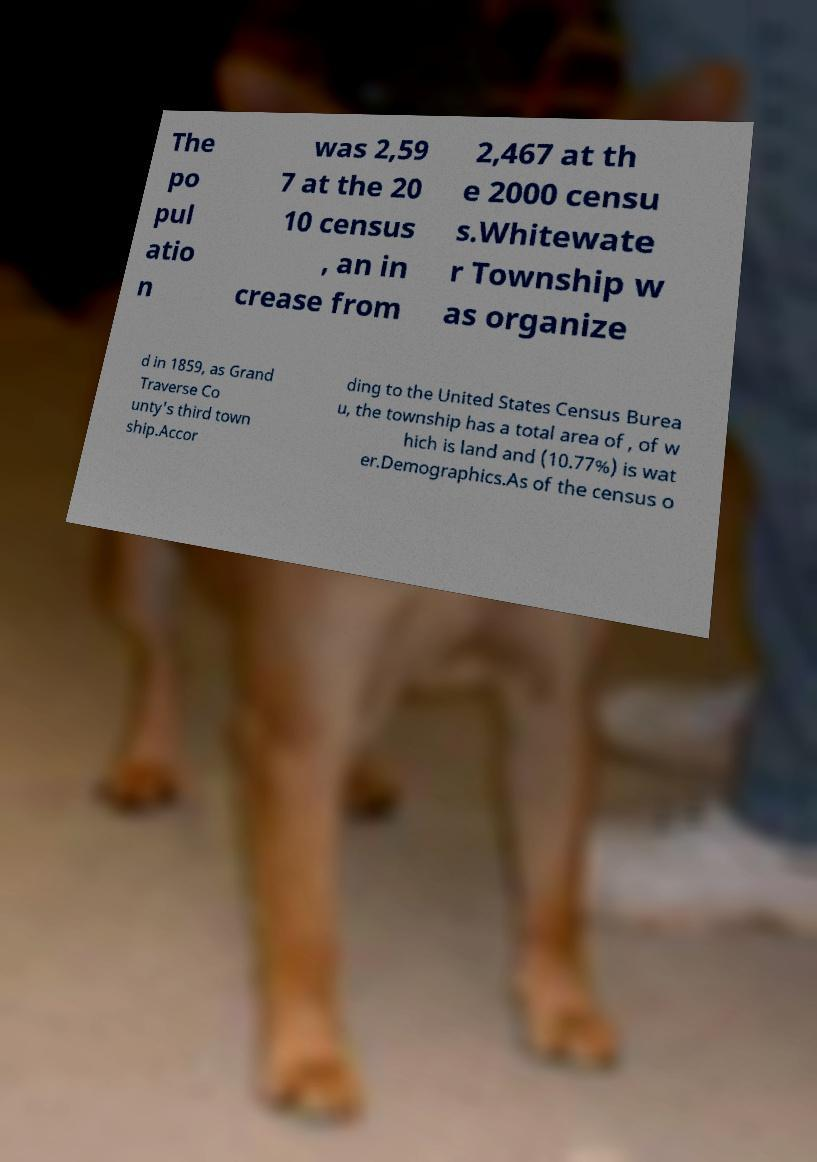What messages or text are displayed in this image? I need them in a readable, typed format. The po pul atio n was 2,59 7 at the 20 10 census , an in crease from 2,467 at th e 2000 censu s.Whitewate r Township w as organize d in 1859, as Grand Traverse Co unty's third town ship.Accor ding to the United States Census Burea u, the township has a total area of , of w hich is land and (10.77%) is wat er.Demographics.As of the census o 